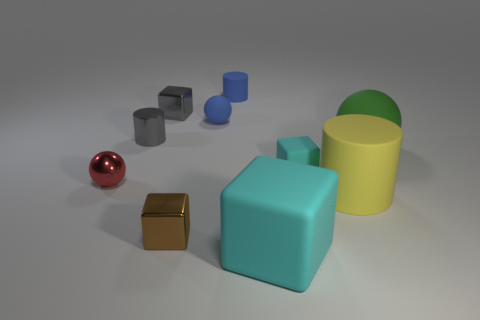Subtract all balls. How many objects are left? 7 Add 2 gray metallic blocks. How many gray metallic blocks are left? 3 Add 1 shiny balls. How many shiny balls exist? 2 Subtract 0 cyan spheres. How many objects are left? 10 Subtract all tiny gray matte cylinders. Subtract all yellow matte cylinders. How many objects are left? 9 